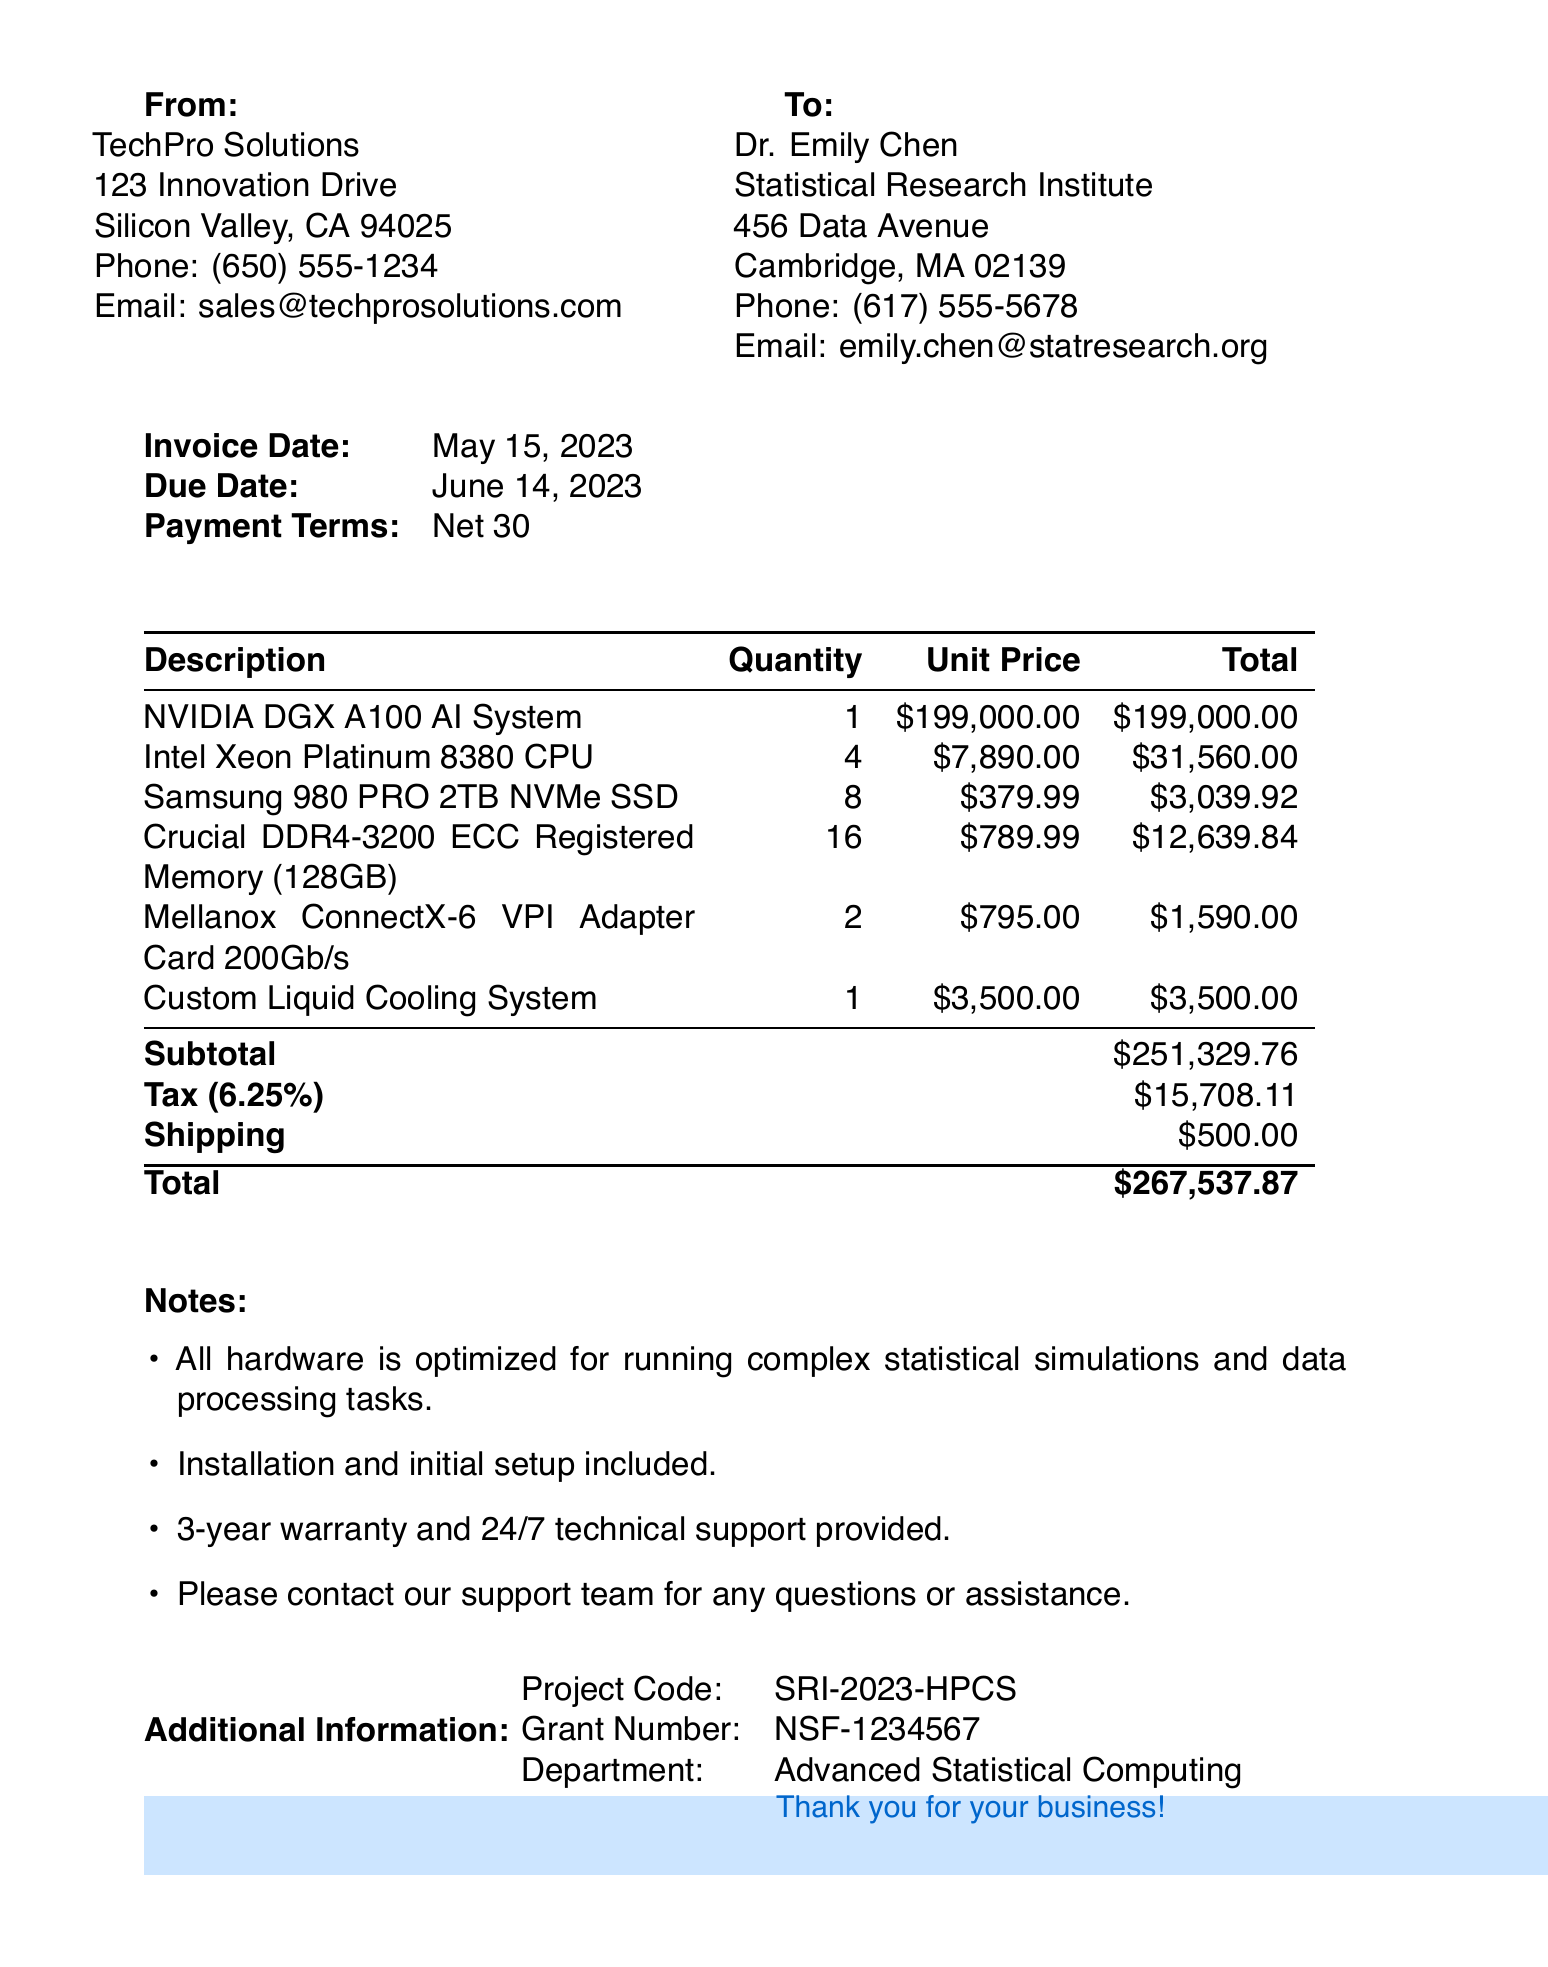What is the invoice number? The invoice number is a unique identifier found at the top of the document.
Answer: INV-2023-05-15-001 Who is the seller? The seller's name and contact details are provided at the beginning of the invoice.
Answer: TechPro Solutions What is the total amount due? The total amount due is the final sum at the bottom of the invoice.
Answer: $267,537.87 What is the tax rate applied to this invoice? The tax rate is specified within the details of the invoice calculations.
Answer: 6.25% How many NVIDIA DGX A100 AI Systems were purchased? The quantity of items purchased is listed alongside the item descriptions.
Answer: 1 What is the project code? The project code is a custom identifier provided in the additional information section of the invoice.
Answer: SRI-2023-HPCS When was the invoice created? The creation date of the invoice is indicated prominently near the top.
Answer: May 15, 2023 What type of terms are specified for payment? The payment terms define when the payment is expected, as noted in the invoice details.
Answer: Net 30 What is included with the purchase? The notes section outlines additional services and guarantees offered with the hardware purchase.
Answer: Installation and initial setup included 